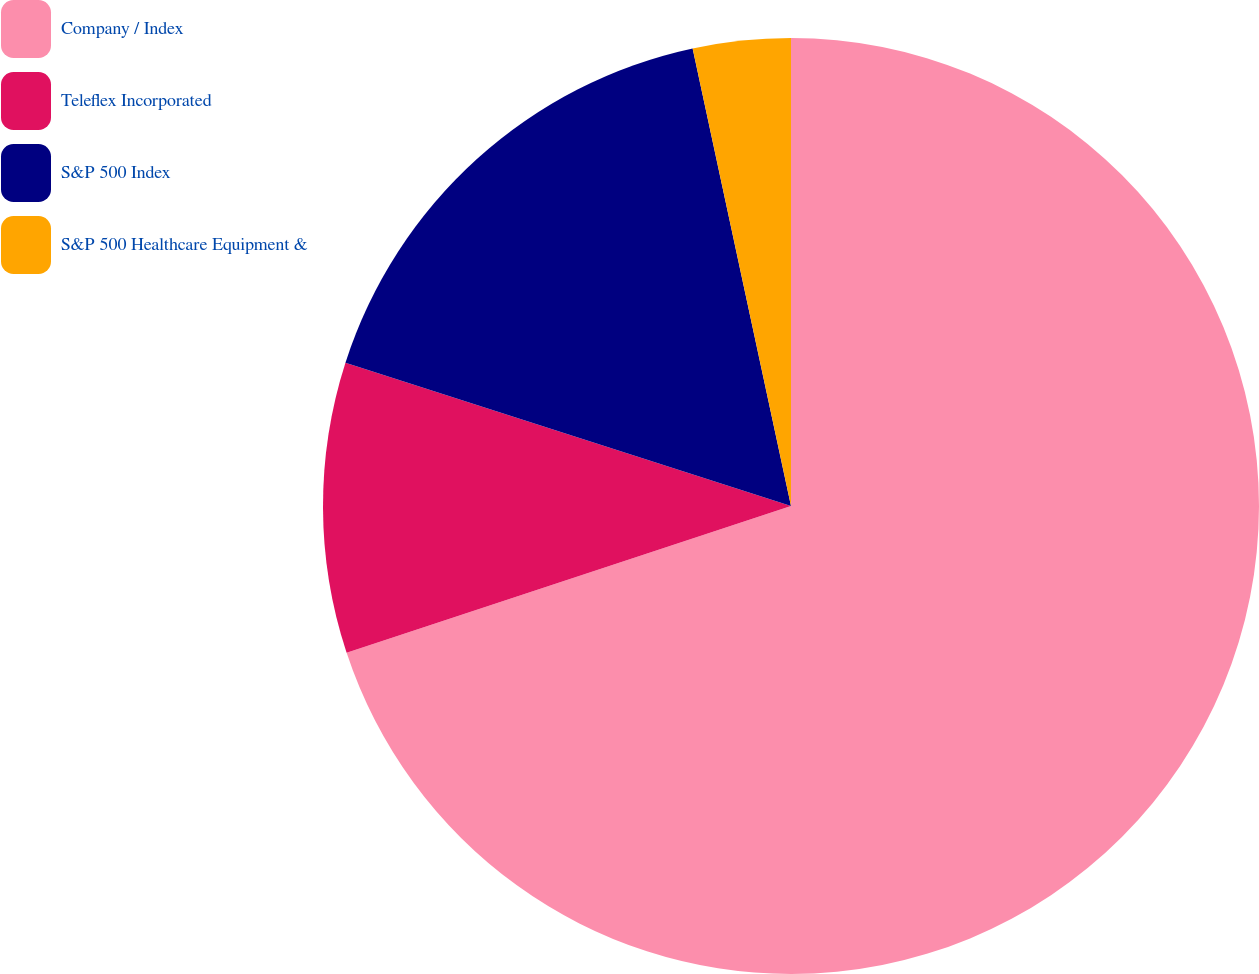Convert chart. <chart><loc_0><loc_0><loc_500><loc_500><pie_chart><fcel>Company / Index<fcel>Teleflex Incorporated<fcel>S&P 500 Index<fcel>S&P 500 Healthcare Equipment &<nl><fcel>69.92%<fcel>10.03%<fcel>16.68%<fcel>3.37%<nl></chart> 